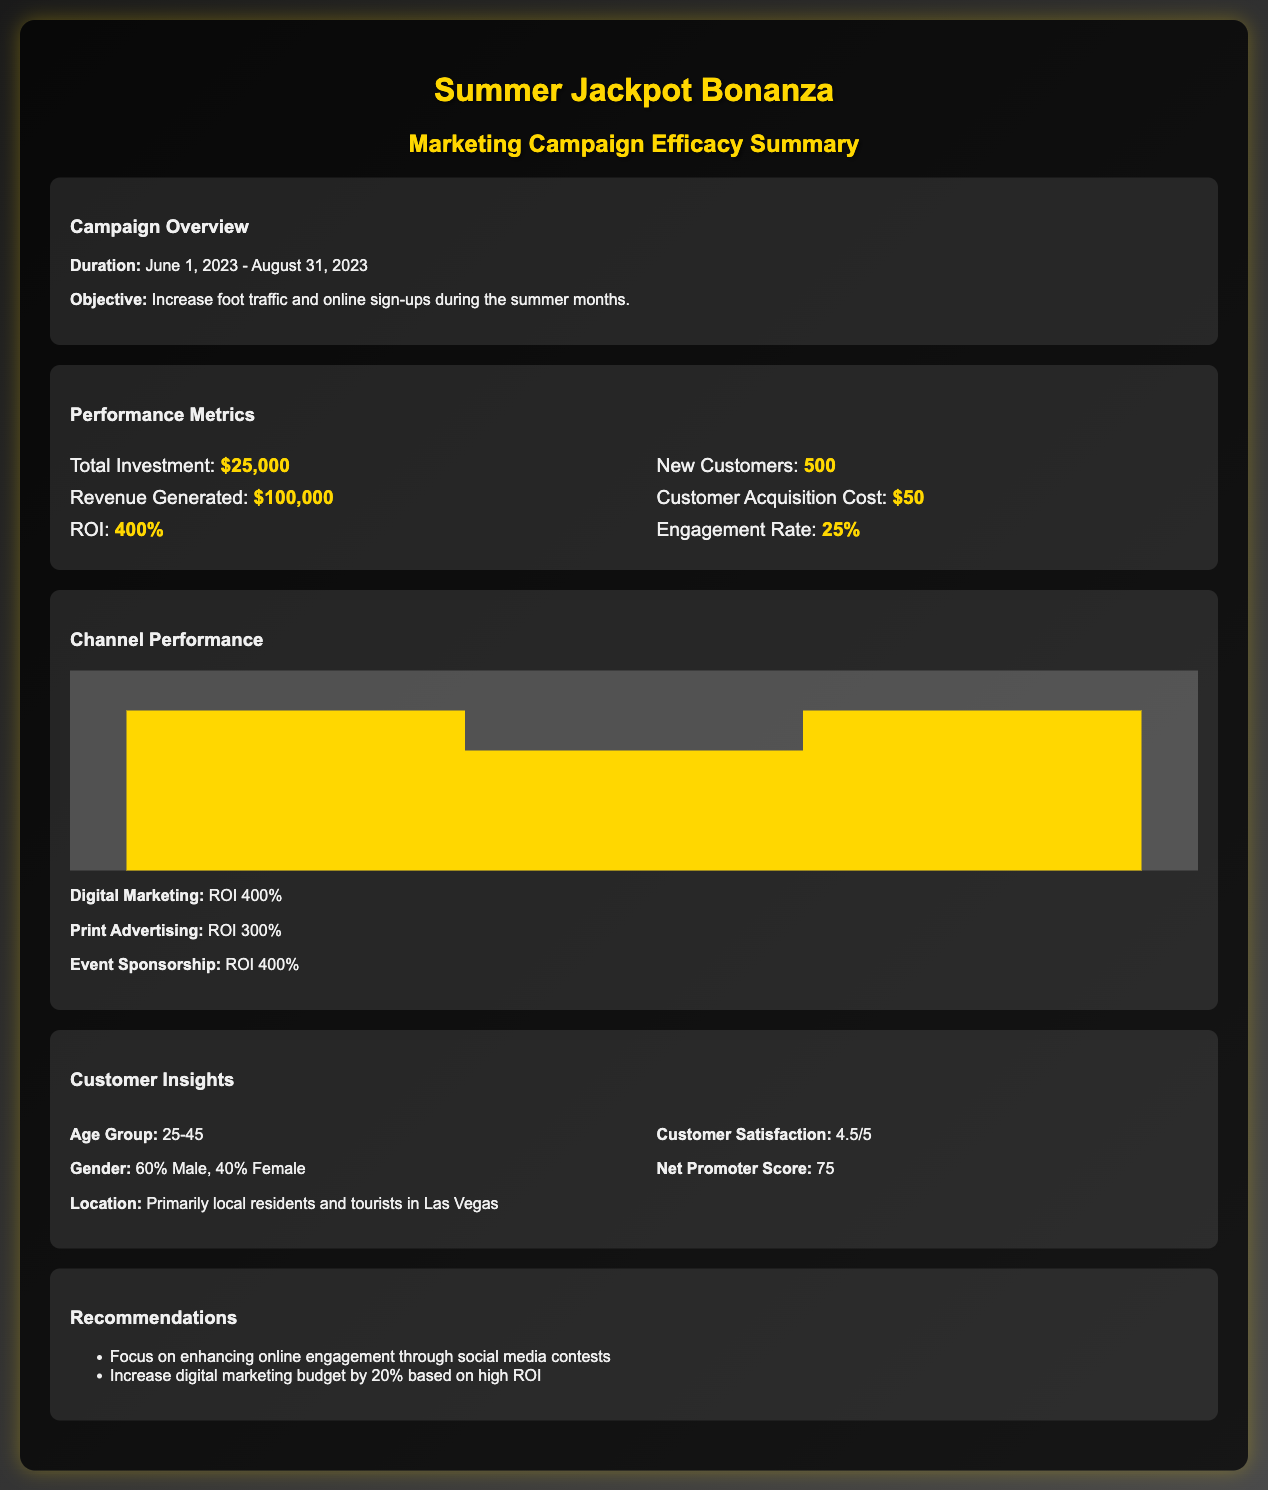What was the total investment for the campaign? The total investment is specified directly in the performance metrics section, which states it was $25,000.
Answer: $25,000 What is the ROI of the Summer Jackpot Bonanza campaign? The ROI is explicitly mentioned in the performance metrics, listed as 400%.
Answer: 400% How many new customers were acquired during the campaign? The document states that the campaign resulted in 500 new customers.
Answer: 500 What is the Customer Acquisition Cost? The customer acquisition cost is provided in the performance metrics as $50.
Answer: $50 Which marketing channel had the highest ROI? The channel performance section indicates that both digital marketing and event sponsorship had the same highest ROI of 400%.
Answer: Digital Marketing and Event Sponsorship What was the customer satisfaction score given by the participants? This information is found under customer insights, where it states the score is 4.5 out of 5.
Answer: 4.5/5 What percentage of the new customers were male? The document specifies that 60% of the new customers were male.
Answer: 60% What is the primary target age group for the campaign? The age group for the campaign is mentioned as 25-45 years.
Answer: 25-45 What recommendation is made regarding the digital marketing budget? One recommendation states to increase the digital marketing budget by 20%.
Answer: Increase by 20% What was the Net Promoter Score for the campaign? The Net Promoter Score is listed in customer insights, which shows a score of 75.
Answer: 75 